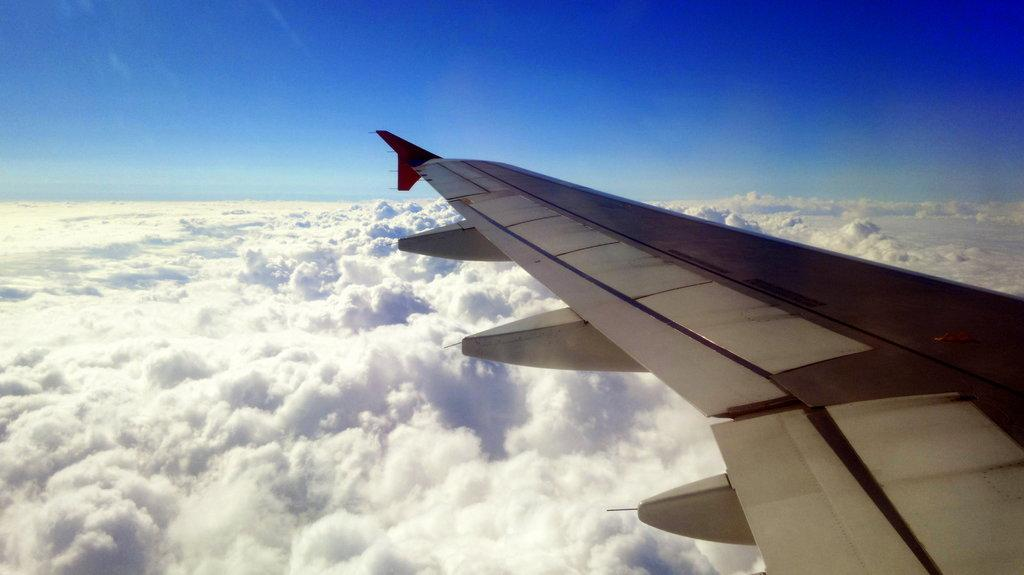What can be seen on the right side of the image? There is a wing of a flight on the right side of the image. What type of natural formations are visible in the image? There are clouds visible in the image. What is visible in the background of the image? The sky is visible in the image. What type of basket is being used to answer questions in the image? There is no basket or act of answering questions present in the image. 